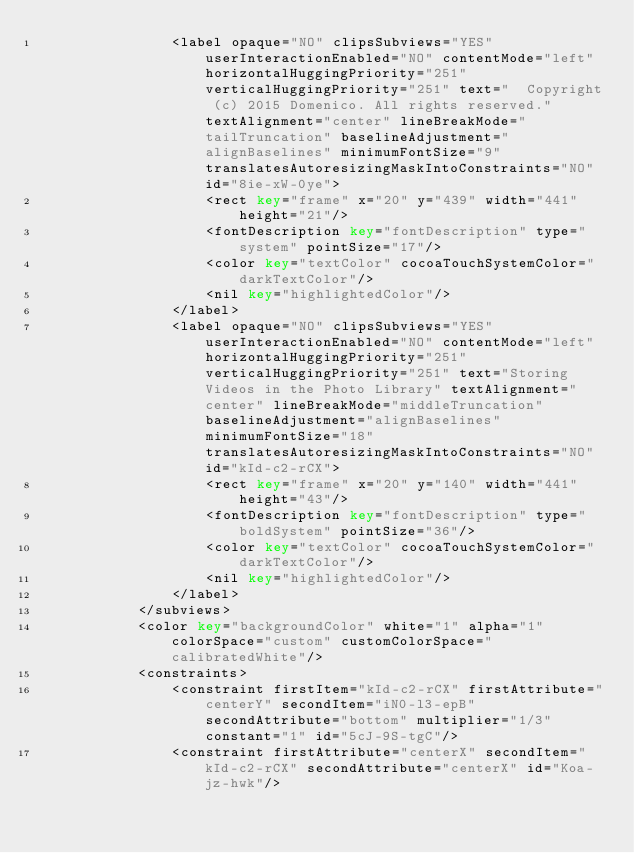Convert code to text. <code><loc_0><loc_0><loc_500><loc_500><_XML_>                <label opaque="NO" clipsSubviews="YES" userInteractionEnabled="NO" contentMode="left" horizontalHuggingPriority="251" verticalHuggingPriority="251" text="  Copyright (c) 2015 Domenico. All rights reserved." textAlignment="center" lineBreakMode="tailTruncation" baselineAdjustment="alignBaselines" minimumFontSize="9" translatesAutoresizingMaskIntoConstraints="NO" id="8ie-xW-0ye">
                    <rect key="frame" x="20" y="439" width="441" height="21"/>
                    <fontDescription key="fontDescription" type="system" pointSize="17"/>
                    <color key="textColor" cocoaTouchSystemColor="darkTextColor"/>
                    <nil key="highlightedColor"/>
                </label>
                <label opaque="NO" clipsSubviews="YES" userInteractionEnabled="NO" contentMode="left" horizontalHuggingPriority="251" verticalHuggingPriority="251" text="Storing Videos in the Photo Library" textAlignment="center" lineBreakMode="middleTruncation" baselineAdjustment="alignBaselines" minimumFontSize="18" translatesAutoresizingMaskIntoConstraints="NO" id="kId-c2-rCX">
                    <rect key="frame" x="20" y="140" width="441" height="43"/>
                    <fontDescription key="fontDescription" type="boldSystem" pointSize="36"/>
                    <color key="textColor" cocoaTouchSystemColor="darkTextColor"/>
                    <nil key="highlightedColor"/>
                </label>
            </subviews>
            <color key="backgroundColor" white="1" alpha="1" colorSpace="custom" customColorSpace="calibratedWhite"/>
            <constraints>
                <constraint firstItem="kId-c2-rCX" firstAttribute="centerY" secondItem="iN0-l3-epB" secondAttribute="bottom" multiplier="1/3" constant="1" id="5cJ-9S-tgC"/>
                <constraint firstAttribute="centerX" secondItem="kId-c2-rCX" secondAttribute="centerX" id="Koa-jz-hwk"/></code> 